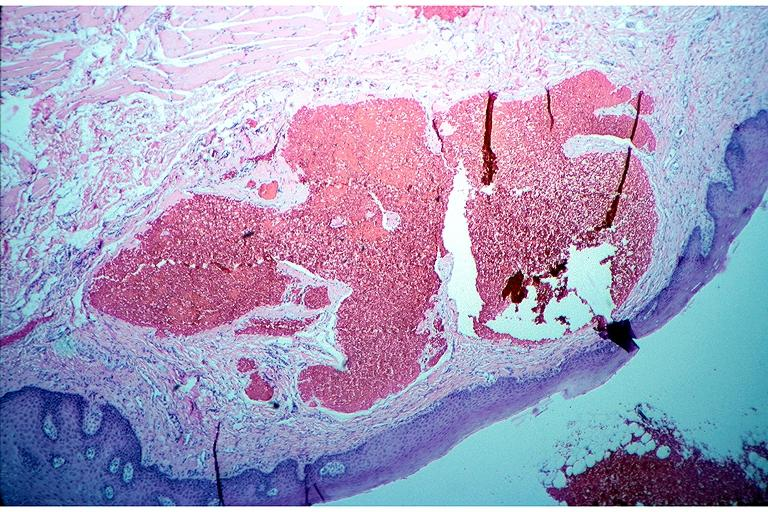does malignant histiocytosis show cavernous hemangioma?
Answer the question using a single word or phrase. No 